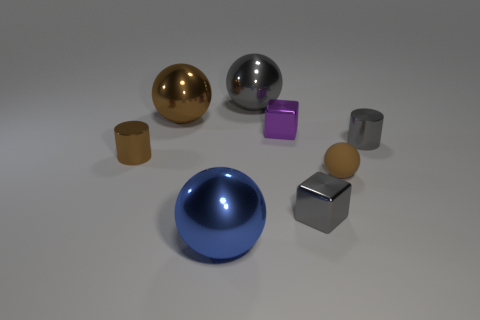Is there any other thing that has the same size as the purple metallic thing?
Your response must be concise. Yes. There is a shiny object that is to the right of the tiny metal thing in front of the small metal cylinder that is on the left side of the big brown shiny thing; what is its shape?
Keep it short and to the point. Cylinder. What number of other objects are the same color as the tiny matte thing?
Ensure brevity in your answer.  2. What shape is the gray object that is behind the large brown thing that is behind the small brown cylinder?
Keep it short and to the point. Sphere. What number of big spheres are left of the gray shiny sphere?
Your response must be concise. 2. Is there a small brown thing that has the same material as the small brown cylinder?
Your answer should be compact. No. There is a purple thing that is the same size as the brown matte sphere; what material is it?
Your answer should be compact. Metal. There is a gray metal thing that is both behind the brown shiny cylinder and in front of the gray metallic ball; what size is it?
Offer a very short reply. Small. What color is the small object that is to the right of the purple object and behind the brown metallic cylinder?
Your answer should be very brief. Gray. Is the number of tiny balls to the left of the big gray ball less than the number of tiny purple metal objects that are in front of the blue metallic ball?
Keep it short and to the point. No. 